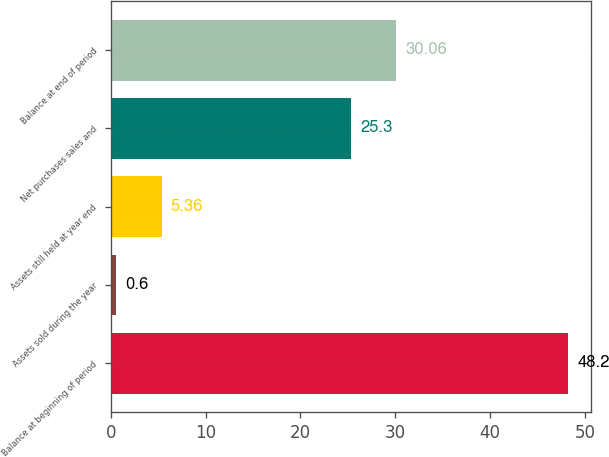<chart> <loc_0><loc_0><loc_500><loc_500><bar_chart><fcel>Balance at beginning of period<fcel>Assets sold during the year<fcel>Assets still held at year end<fcel>Net purchases sales and<fcel>Balance at end of period<nl><fcel>48.2<fcel>0.6<fcel>5.36<fcel>25.3<fcel>30.06<nl></chart> 